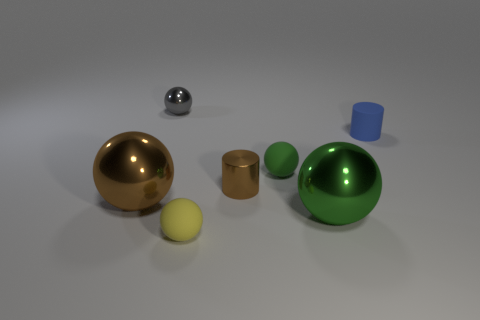Add 3 big yellow objects. How many objects exist? 10 How many green balls must be subtracted to get 1 green balls? 1 Subtract 2 balls. How many balls are left? 3 Subtract all gray balls. Subtract all green cylinders. How many balls are left? 4 Subtract all purple balls. How many blue cylinders are left? 1 Subtract all tiny gray spheres. Subtract all green shiny cylinders. How many objects are left? 6 Add 5 tiny green matte spheres. How many tiny green matte spheres are left? 6 Add 3 purple rubber things. How many purple rubber things exist? 3 Subtract all brown cylinders. How many cylinders are left? 1 Subtract all big brown shiny balls. How many balls are left? 4 